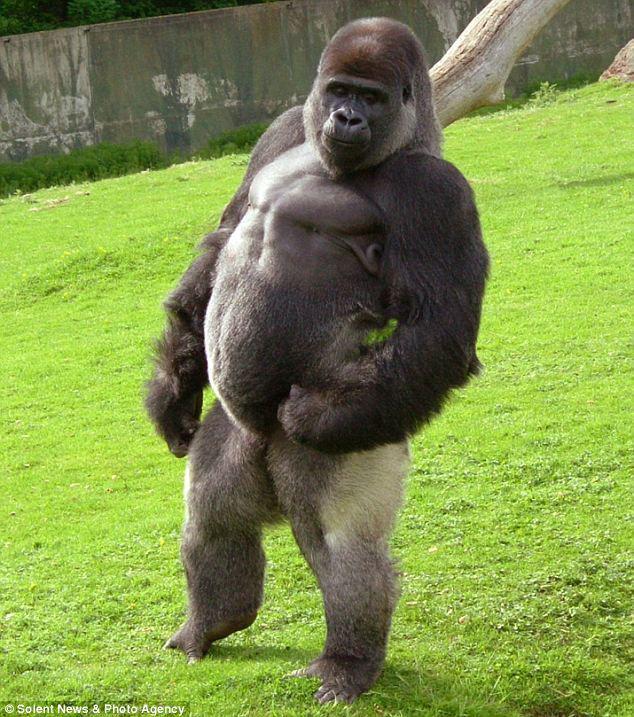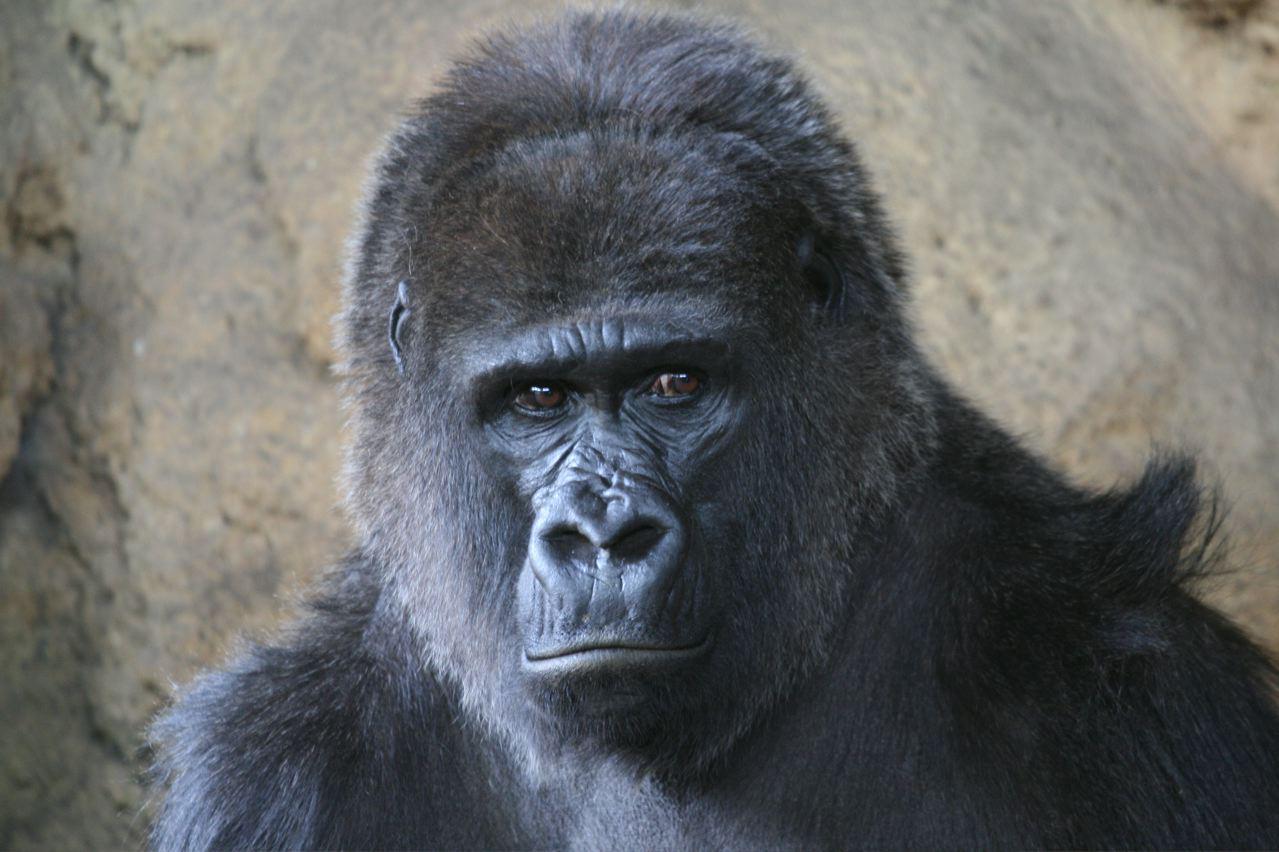The first image is the image on the left, the second image is the image on the right. Assess this claim about the two images: "One image shows a gorilla standing up straight, and the other shows a gorilla turning its head to eye the camera, with one elbow bent and hand near its chin.". Correct or not? Answer yes or no. No. The first image is the image on the left, the second image is the image on the right. Considering the images on both sides, is "A concrete barrier can be seen behind the ape in the image on the left." valid? Answer yes or no. Yes. 